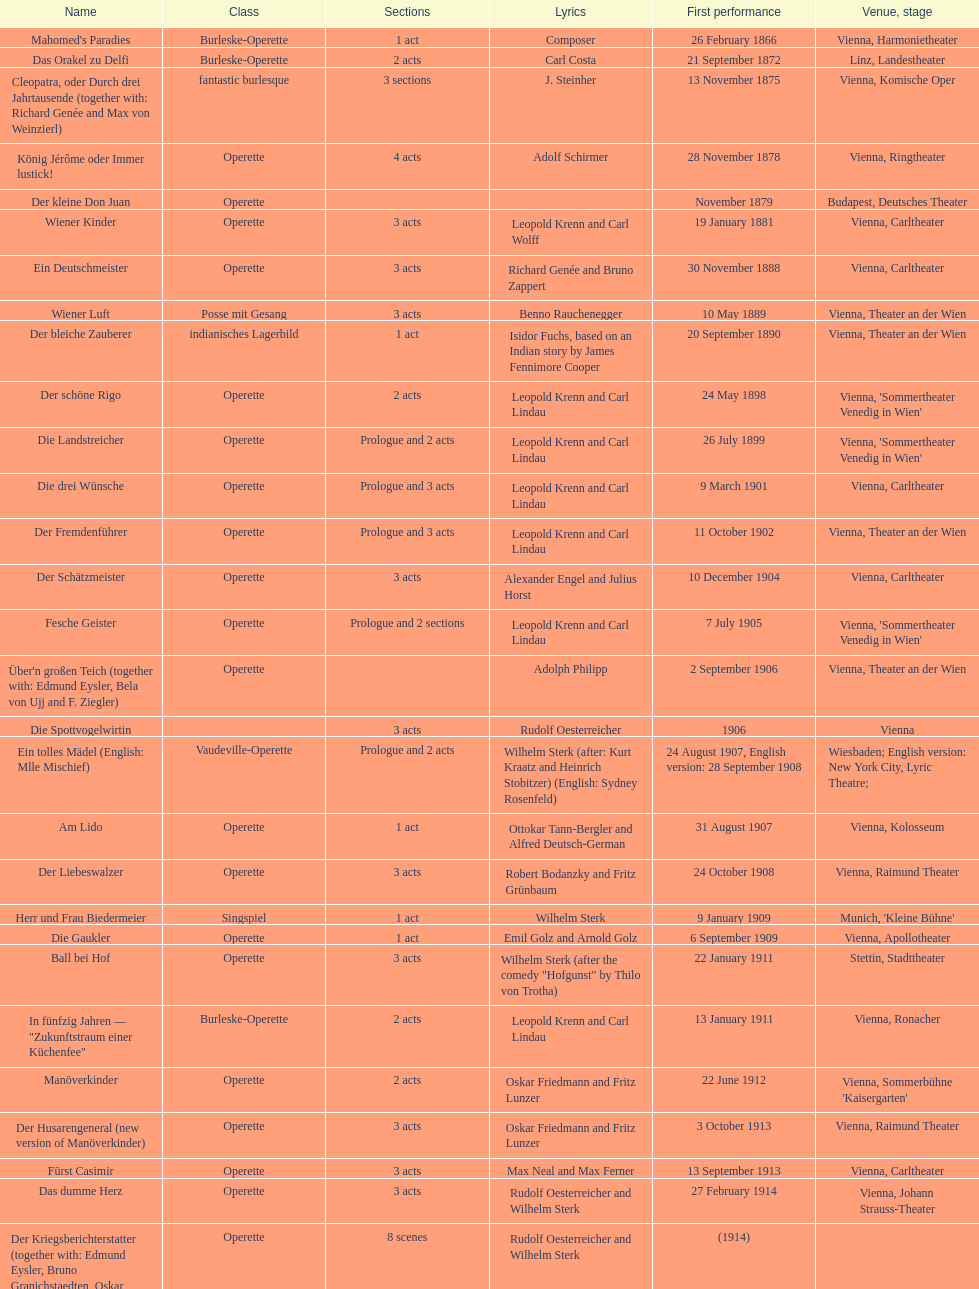How many of his operettas were 3 acts? 13. 